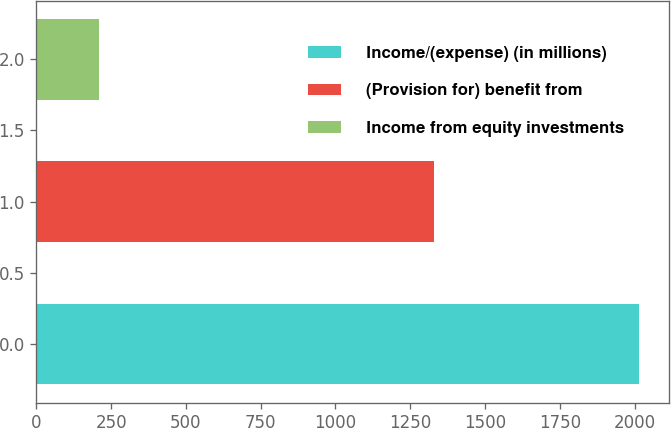<chart> <loc_0><loc_0><loc_500><loc_500><bar_chart><fcel>Income/(expense) (in millions)<fcel>(Provision for) benefit from<fcel>Income from equity investments<nl><fcel>2015<fcel>1330<fcel>208<nl></chart> 